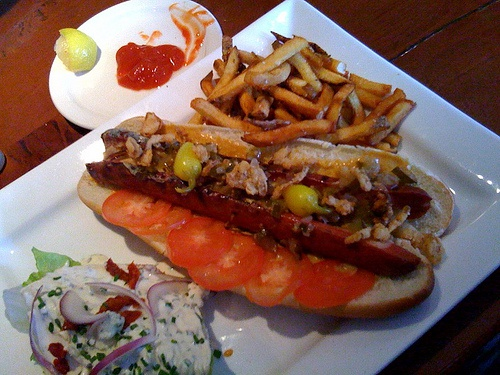Describe the objects in this image and their specific colors. I can see a hot dog in navy, maroon, black, and brown tones in this image. 